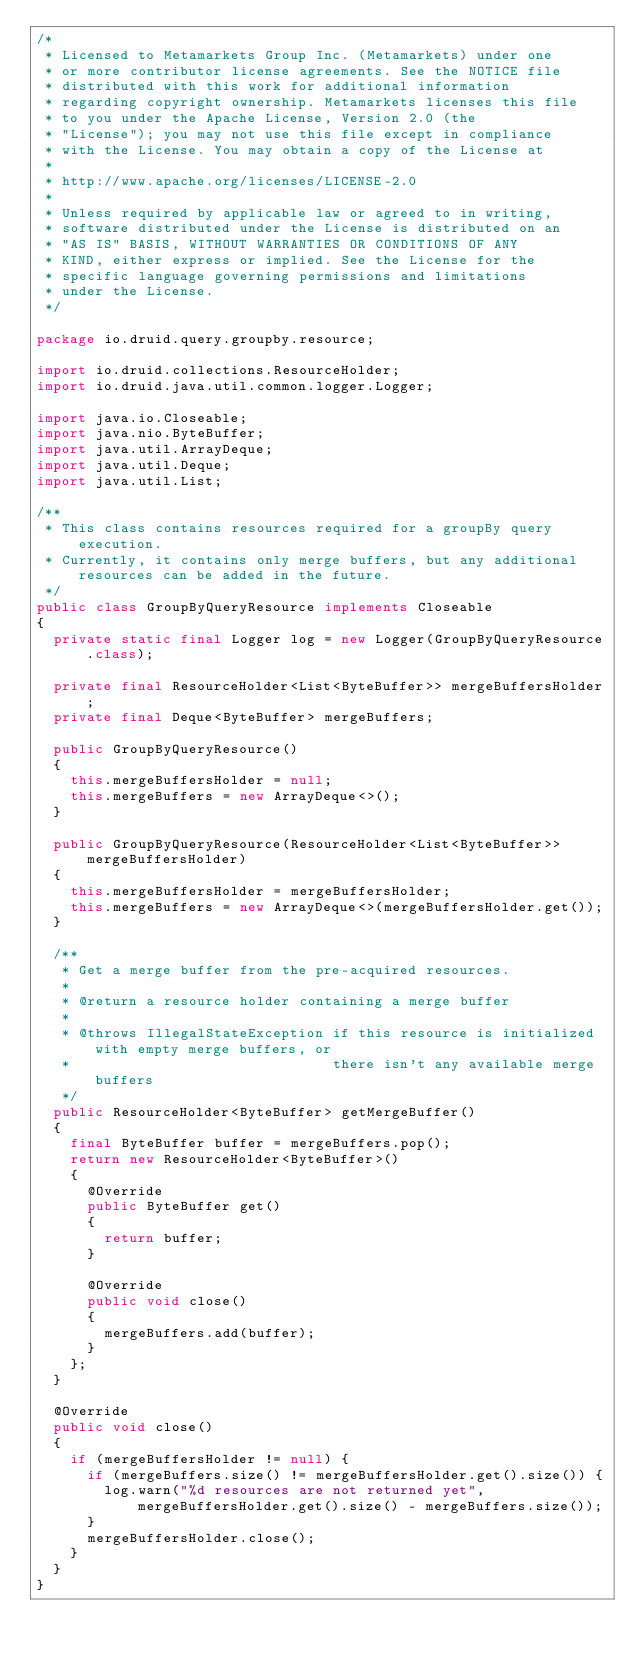Convert code to text. <code><loc_0><loc_0><loc_500><loc_500><_Java_>/*
 * Licensed to Metamarkets Group Inc. (Metamarkets) under one
 * or more contributor license agreements. See the NOTICE file
 * distributed with this work for additional information
 * regarding copyright ownership. Metamarkets licenses this file
 * to you under the Apache License, Version 2.0 (the
 * "License"); you may not use this file except in compliance
 * with the License. You may obtain a copy of the License at
 *
 * http://www.apache.org/licenses/LICENSE-2.0
 *
 * Unless required by applicable law or agreed to in writing,
 * software distributed under the License is distributed on an
 * "AS IS" BASIS, WITHOUT WARRANTIES OR CONDITIONS OF ANY
 * KIND, either express or implied. See the License for the
 * specific language governing permissions and limitations
 * under the License.
 */

package io.druid.query.groupby.resource;

import io.druid.collections.ResourceHolder;
import io.druid.java.util.common.logger.Logger;

import java.io.Closeable;
import java.nio.ByteBuffer;
import java.util.ArrayDeque;
import java.util.Deque;
import java.util.List;

/**
 * This class contains resources required for a groupBy query execution.
 * Currently, it contains only merge buffers, but any additional resources can be added in the future.
 */
public class GroupByQueryResource implements Closeable
{
  private static final Logger log = new Logger(GroupByQueryResource.class);

  private final ResourceHolder<List<ByteBuffer>> mergeBuffersHolder;
  private final Deque<ByteBuffer> mergeBuffers;

  public GroupByQueryResource()
  {
    this.mergeBuffersHolder = null;
    this.mergeBuffers = new ArrayDeque<>();
  }

  public GroupByQueryResource(ResourceHolder<List<ByteBuffer>> mergeBuffersHolder)
  {
    this.mergeBuffersHolder = mergeBuffersHolder;
    this.mergeBuffers = new ArrayDeque<>(mergeBuffersHolder.get());
  }

  /**
   * Get a merge buffer from the pre-acquired resources.
   *
   * @return a resource holder containing a merge buffer
   *
   * @throws IllegalStateException if this resource is initialized with empty merge buffers, or
   *                               there isn't any available merge buffers
   */
  public ResourceHolder<ByteBuffer> getMergeBuffer()
  {
    final ByteBuffer buffer = mergeBuffers.pop();
    return new ResourceHolder<ByteBuffer>()
    {
      @Override
      public ByteBuffer get()
      {
        return buffer;
      }

      @Override
      public void close()
      {
        mergeBuffers.add(buffer);
      }
    };
  }

  @Override
  public void close()
  {
    if (mergeBuffersHolder != null) {
      if (mergeBuffers.size() != mergeBuffersHolder.get().size()) {
        log.warn("%d resources are not returned yet", mergeBuffersHolder.get().size() - mergeBuffers.size());
      }
      mergeBuffersHolder.close();
    }
  }
}
</code> 